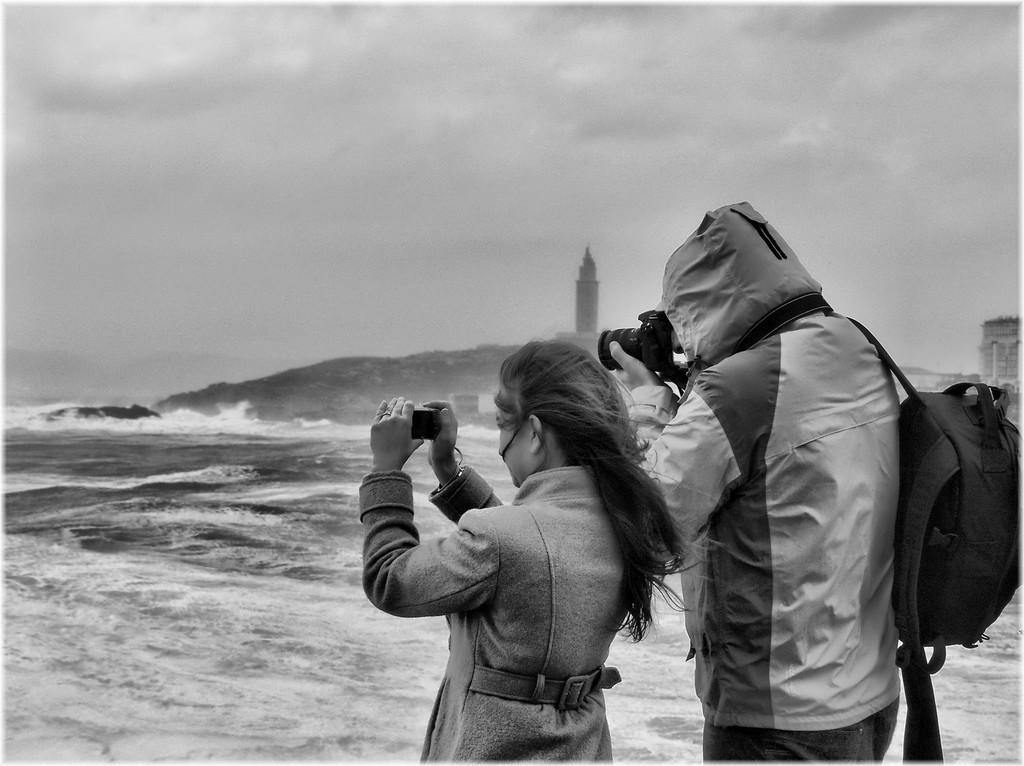Could you give a brief overview of what you see in this image? In the image we can see black and white picture of a woman and a man standing, wearing clothes and holding gadget in their hands. Here on the right side, we can see a person carrying bag. Here we can see water, hill, lighthouse and the sky. 